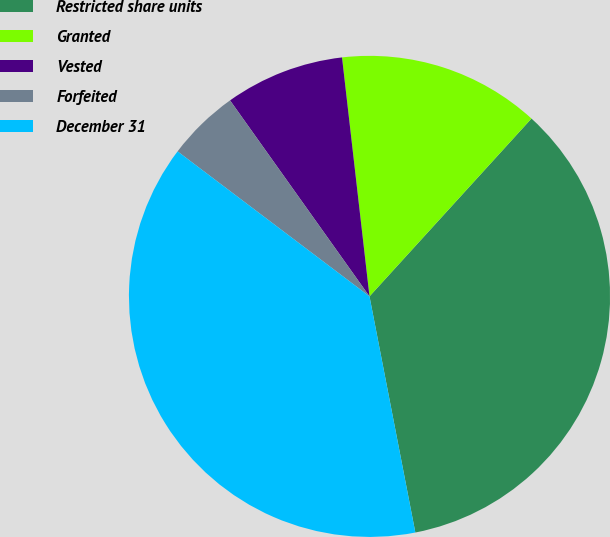<chart> <loc_0><loc_0><loc_500><loc_500><pie_chart><fcel>Restricted share units<fcel>Granted<fcel>Vested<fcel>Forfeited<fcel>December 31<nl><fcel>35.19%<fcel>13.58%<fcel>8.02%<fcel>4.86%<fcel>38.35%<nl></chart> 